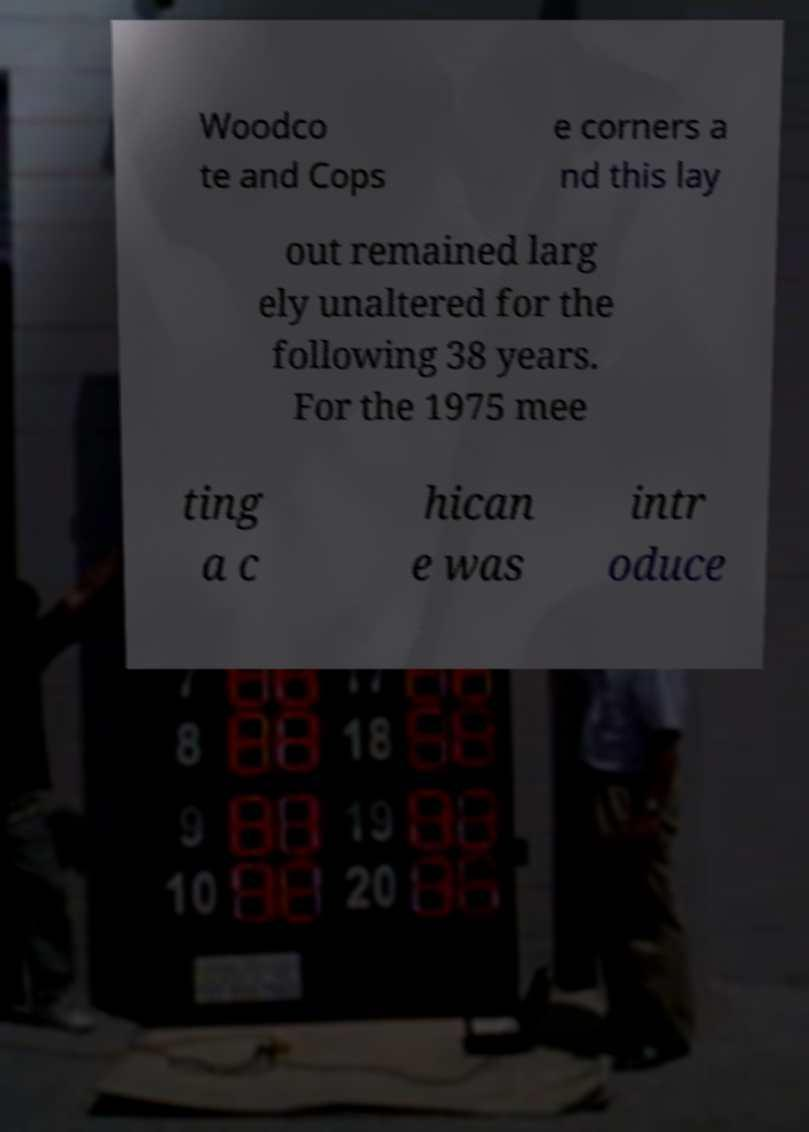Please identify and transcribe the text found in this image. Woodco te and Cops e corners a nd this lay out remained larg ely unaltered for the following 38 years. For the 1975 mee ting a c hican e was intr oduce 